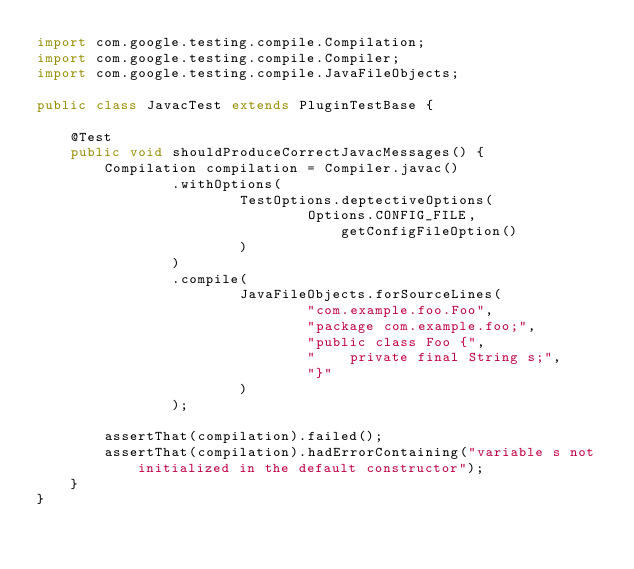<code> <loc_0><loc_0><loc_500><loc_500><_Java_>import com.google.testing.compile.Compilation;
import com.google.testing.compile.Compiler;
import com.google.testing.compile.JavaFileObjects;

public class JavacTest extends PluginTestBase {

    @Test
    public void shouldProduceCorrectJavacMessages() {
        Compilation compilation = Compiler.javac()
                .withOptions(
                        TestOptions.deptectiveOptions(
                                Options.CONFIG_FILE, getConfigFileOption()
                        )
                )
                .compile(
                        JavaFileObjects.forSourceLines(
                                "com.example.foo.Foo",
                                "package com.example.foo;",
                                "public class Foo {",
                                "    private final String s;",
                                "}"
                        )
                );

        assertThat(compilation).failed();
        assertThat(compilation).hadErrorContaining("variable s not initialized in the default constructor");
    }
}
</code> 